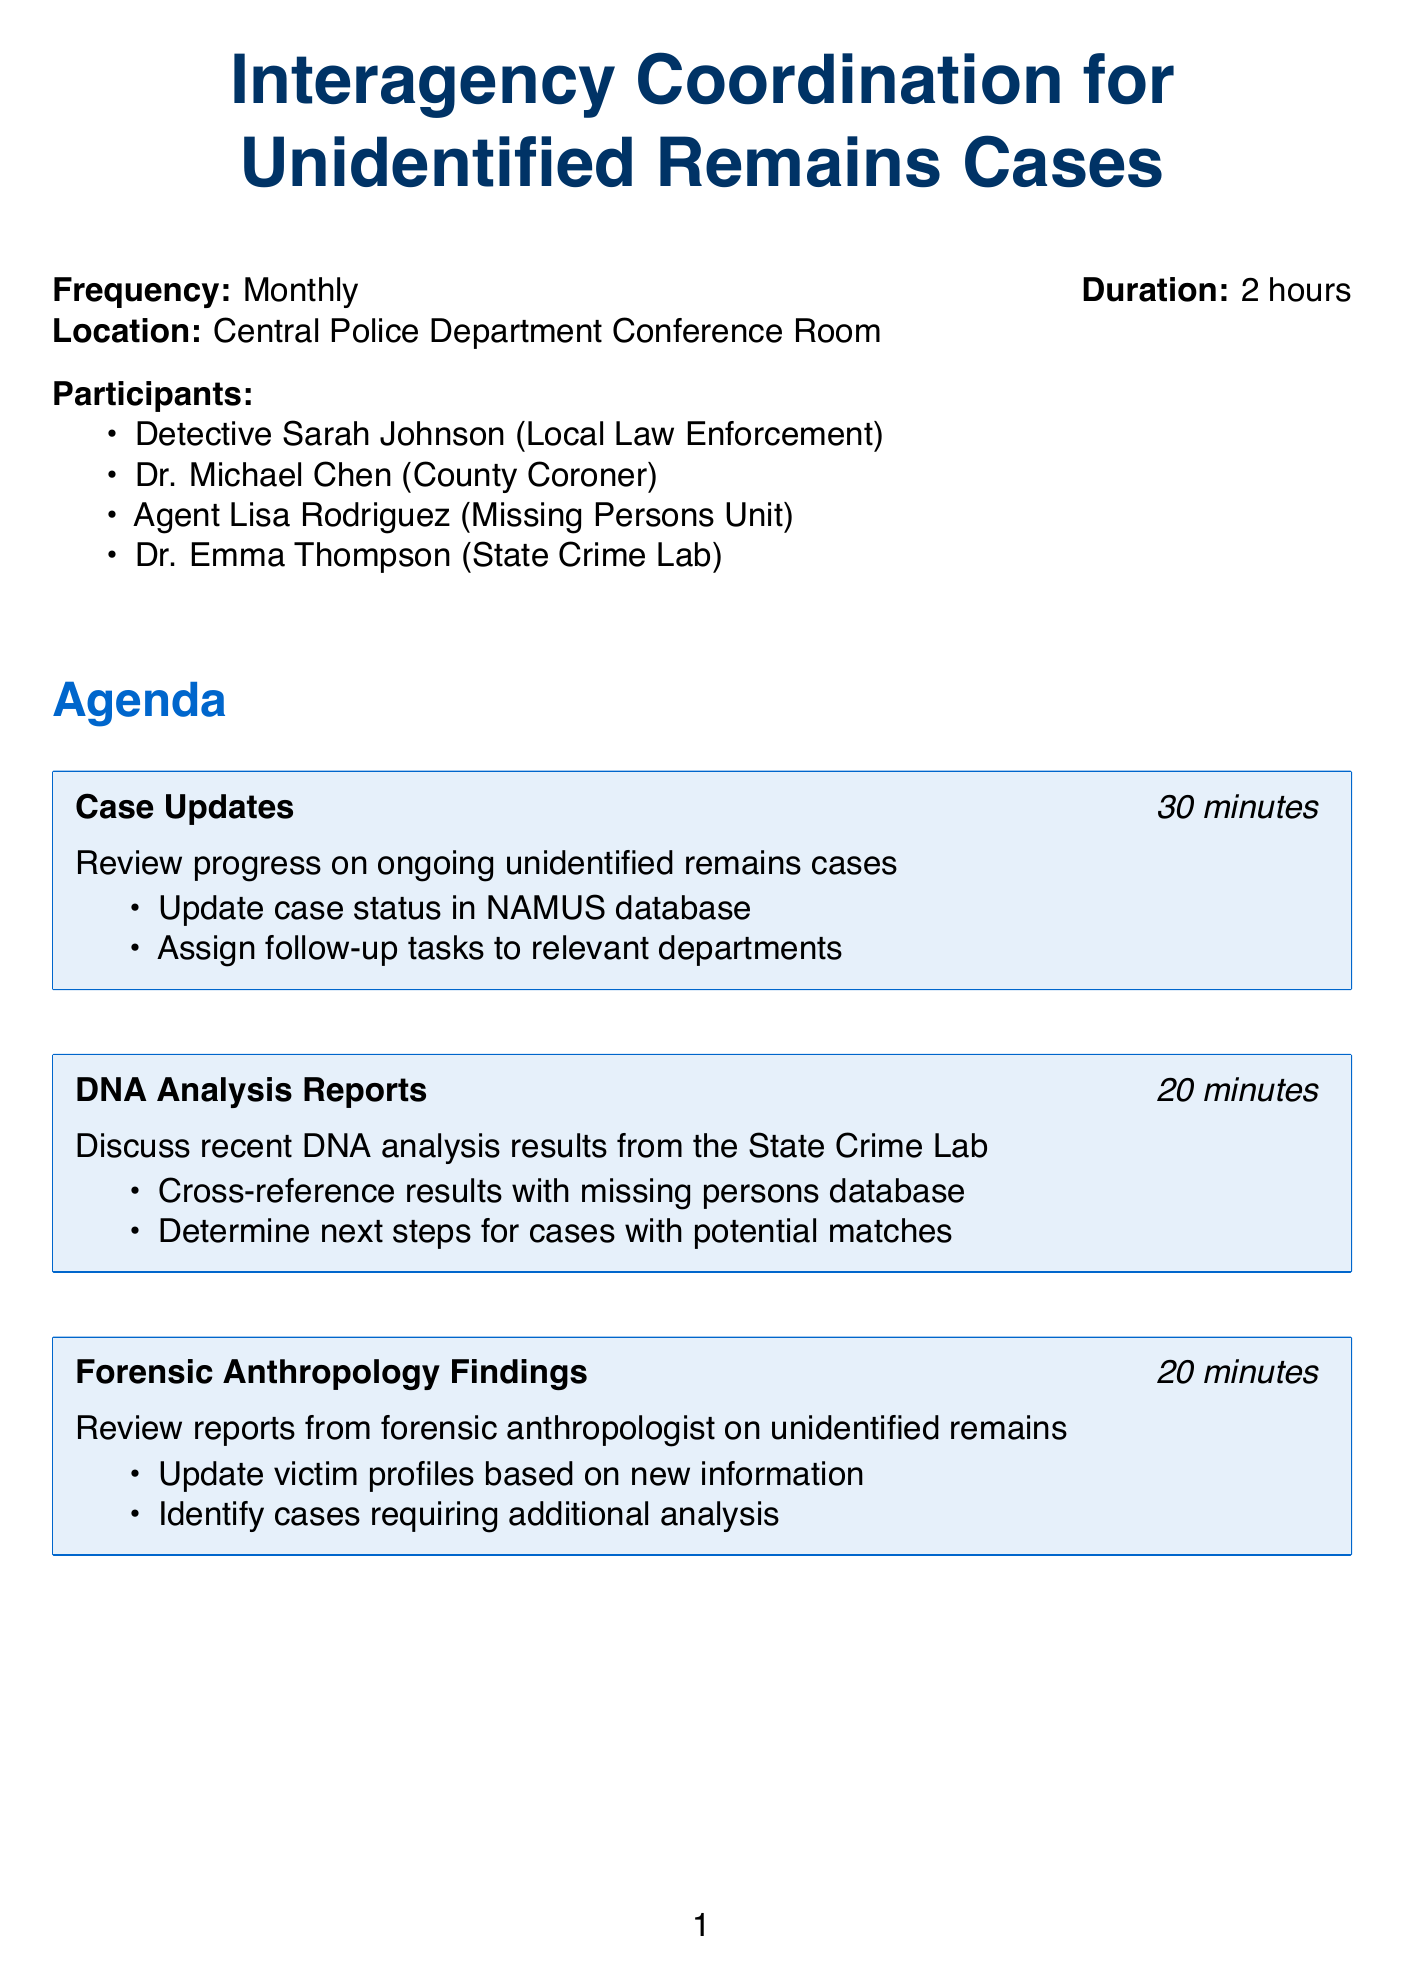What is the meeting title? The title of the meeting is typically the main heading in the document.
Answer: Interagency Coordination for Unidentified Remains Cases How often do the meetings occur? The frequency of the meetings is specified in the document.
Answer: Monthly Who is the County Coroner participant? The document lists the participants and their titles, including the County Coroner.
Answer: Dr. Michael Chen What is the duration of the meetings? The duration is mentioned alongside the frequency at the beginning of the document.
Answer: 2 hours How many action points are associated with the Case Updates agenda item? By counting the items listed under that agenda entry, we determine the number of action points.
Answer: 2 What is one resource listed for additional resources? The additional resources section provides access to certain databases and tools.
Answer: NAMUS (National Missing and Unidentified Persons System) database access What is the total duration allocated for the Public Outreach Initiatives agenda item? Each agenda item includes a specified duration, which can be directly referenced.
Answer: 15 minutes What is the follow-up procedure for distributing meeting minutes? The follow-up procedures outline how quickly meeting minutes should be distributed.
Answer: Distribute meeting minutes within 48 hours How long is the agenda item for DNA Analysis Reports? The duration for each agenda item is specified next to the title.
Answer: 20 minutes 